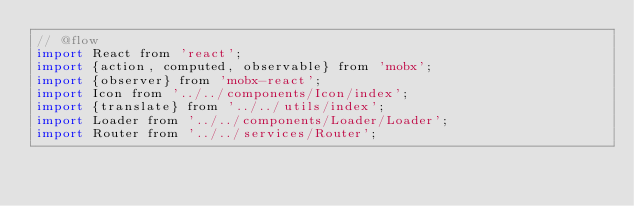<code> <loc_0><loc_0><loc_500><loc_500><_JavaScript_>// @flow
import React from 'react';
import {action, computed, observable} from 'mobx';
import {observer} from 'mobx-react';
import Icon from '../../components/Icon/index';
import {translate} from '../../utils/index';
import Loader from '../../components/Loader/Loader';
import Router from '../../services/Router';</code> 